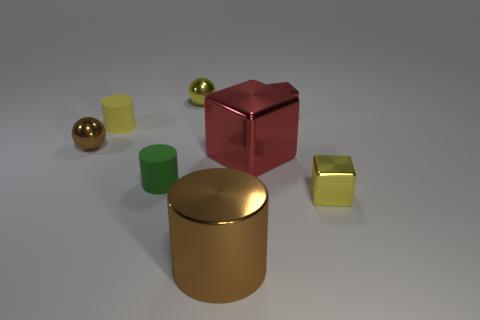Add 1 purple rubber spheres. How many objects exist? 9 Subtract all balls. How many objects are left? 6 Subtract all small green matte things. Subtract all brown things. How many objects are left? 5 Add 2 green rubber cylinders. How many green rubber cylinders are left? 3 Add 1 red objects. How many red objects exist? 3 Subtract 0 green spheres. How many objects are left? 8 